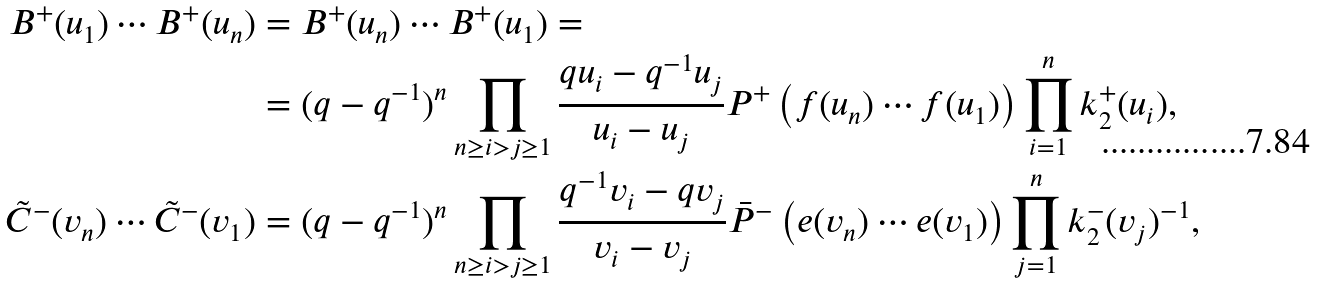Convert formula to latex. <formula><loc_0><loc_0><loc_500><loc_500>B ^ { + } ( u _ { 1 } ) \cdots B ^ { + } ( u _ { n } ) & = B ^ { + } ( u _ { n } ) \cdots B ^ { + } ( u _ { 1 } ) = \\ & = ( q - q ^ { - 1 } ) ^ { n } \prod _ { n \geq i > j \geq 1 } \frac { q u _ { i } - q ^ { - 1 } u _ { j } } { u _ { i } - u _ { j } } P ^ { + } \left ( f ( u _ { n } ) \cdots f ( u _ { 1 } ) \right ) \prod _ { i = 1 } ^ { n } k ^ { + } _ { 2 } ( u _ { i } ) , \\ \tilde { C } ^ { - } ( v _ { n } ) \cdots \tilde { C } ^ { - } ( v _ { 1 } ) & = ( q - q ^ { - 1 } ) ^ { n } \prod _ { n \geq i > j \geq 1 } \frac { q ^ { - 1 } v _ { i } - q v _ { j } } { v _ { i } - v _ { j } } \bar { P } ^ { - } \left ( e ( v _ { n } ) \cdots e ( v _ { 1 } ) \right ) \prod _ { j = 1 } ^ { n } k ^ { - } _ { 2 } ( v _ { j } ) ^ { - 1 } ,</formula> 